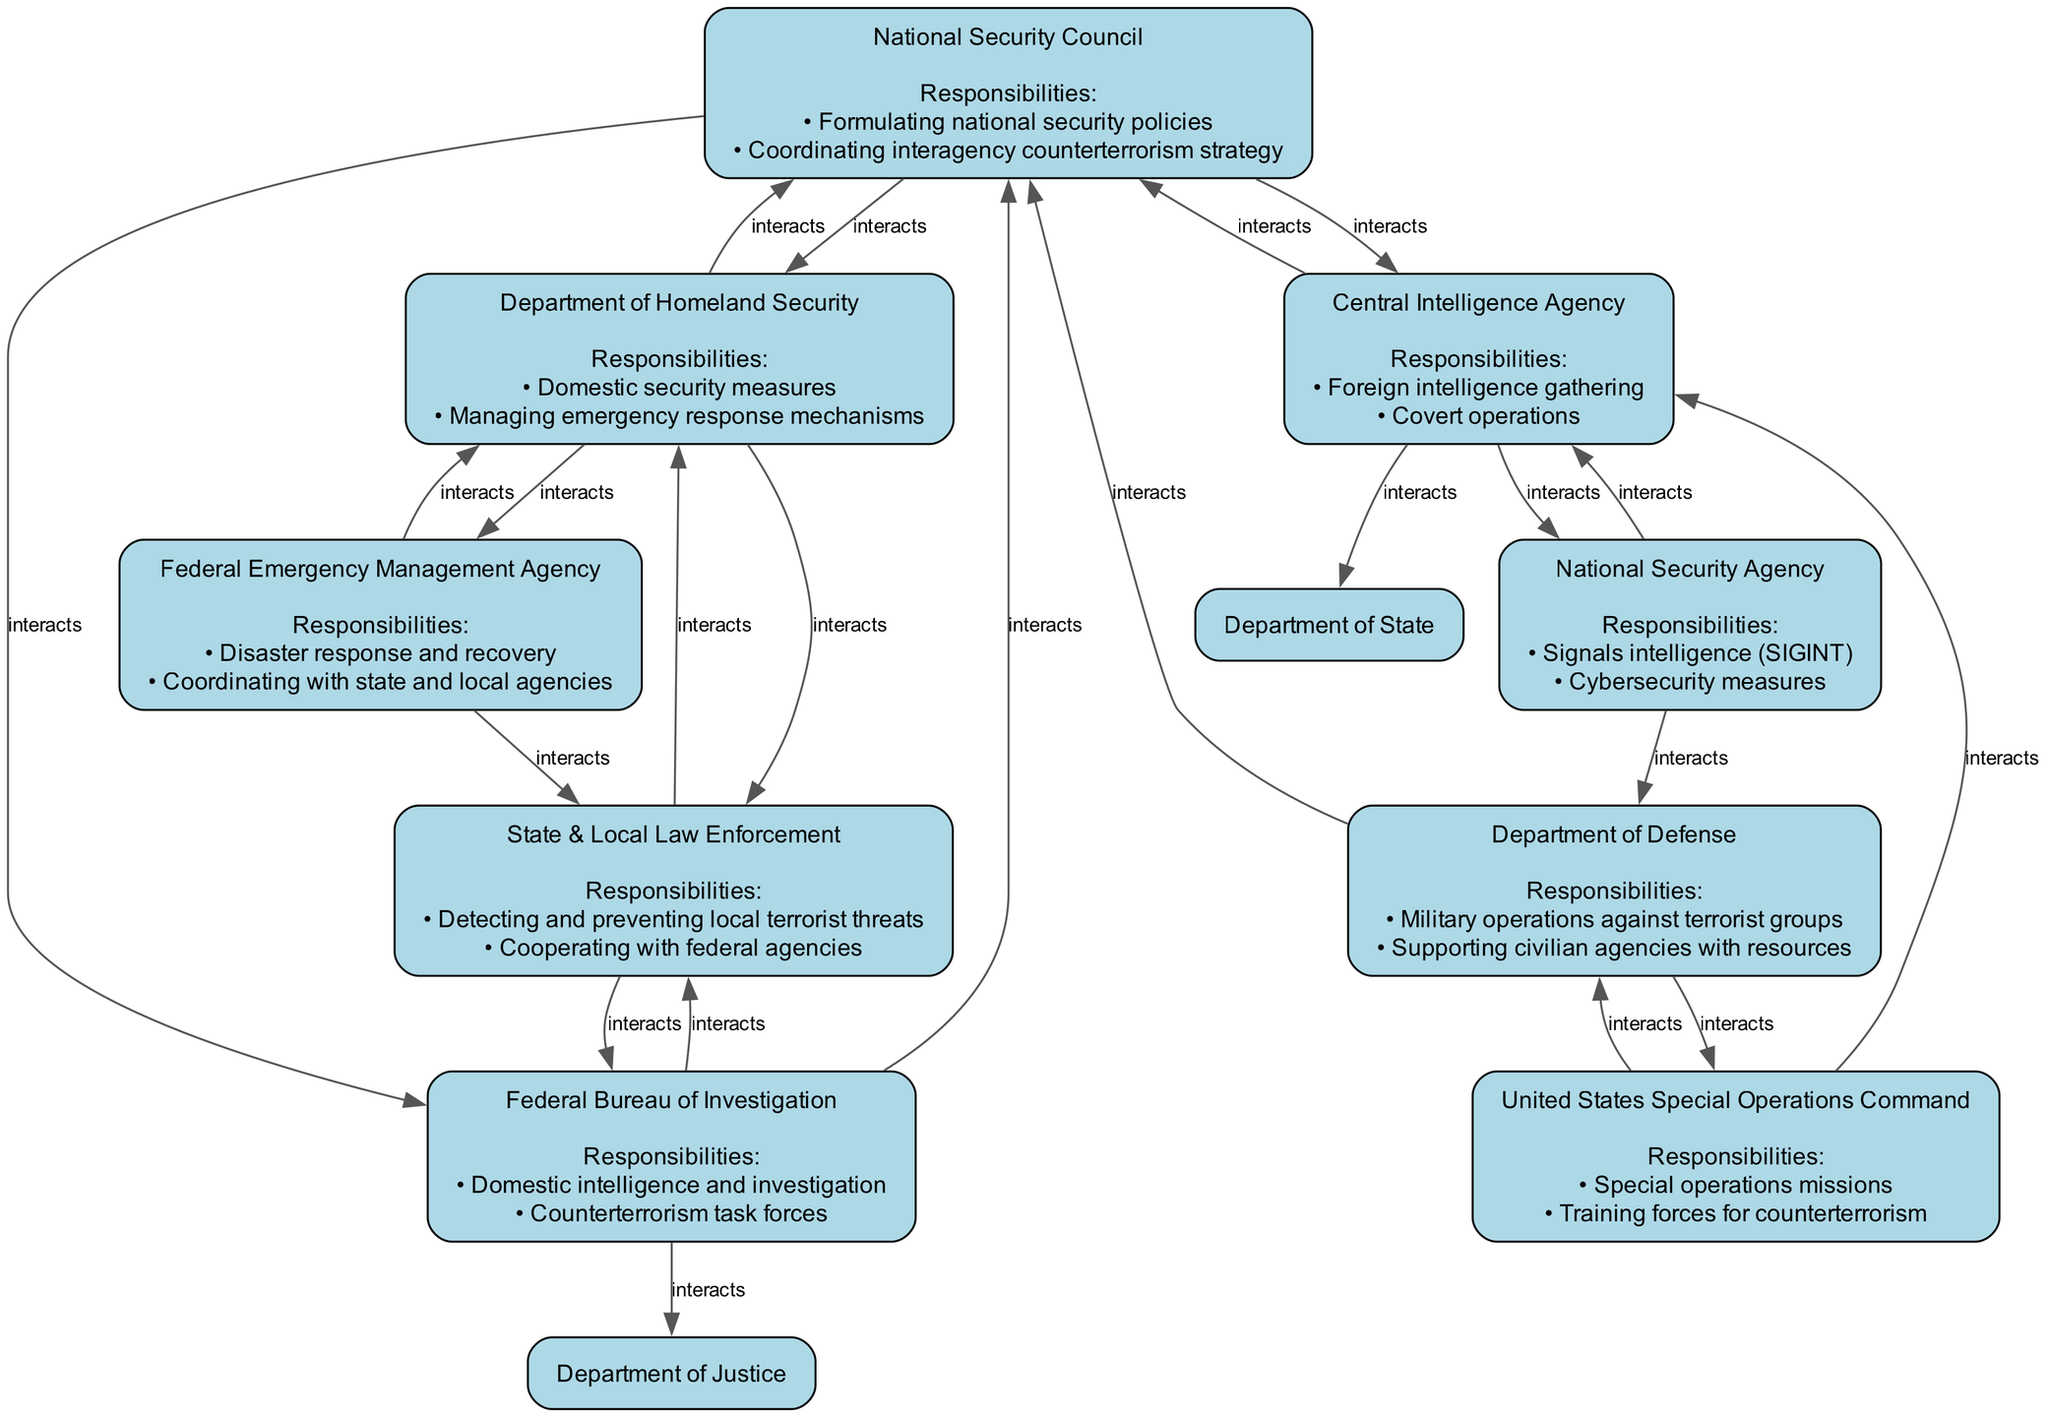What is the primary responsibility of the National Security Council? The National Security Council's primary responsibility is "Formulating national security policies." This is one of the key responsibilities outlined in the diagram for this entity.
Answer: Formulating national security policies How many interactions does the Federal Bureau of Investigation have? The Federal Bureau of Investigation has three interactions listed in the diagram: with the National Security Council, Department of Justice, and State & Local Law Enforcement. Therefore, counting these gives us the total number of interactions.
Answer: Three Which department is responsible for "Military operations against terrorist groups"? According to the diagram, the responsibility of "Military operations against terrorist groups" belongs to the Department of Defense, which denotes its specific role in the counterterrorism command structure.
Answer: Department of Defense What department interacts with both the Central Intelligence Agency and the National Security Agency? The diagram shows that the Central Intelligence Agency interacts with both the National Security Agency and the Department of State, showing its connections in intelligence and cybersecurity measures. Therefore, both the CIA and NSA share interaction with another entity, but the one directly interacting with both is the CIA.
Answer: Central Intelligence Agency Which department is responsible for both "Domestic security measures" and "Managing emergency response mechanisms"? The responsibilities of "Domestic security measures" and "Managing emergency response mechanisms" are assigned to the Department of Homeland Security as detailed in its responsibilities in the diagram.
Answer: Department of Homeland Security How many nodes are there in the diagram? The diagram consists of a total of nine nodes, each representing different departments and agencies responsible for counterterrorism. Counting each entity listed confirms the total number of nodes present in the diagram.
Answer: Nine 